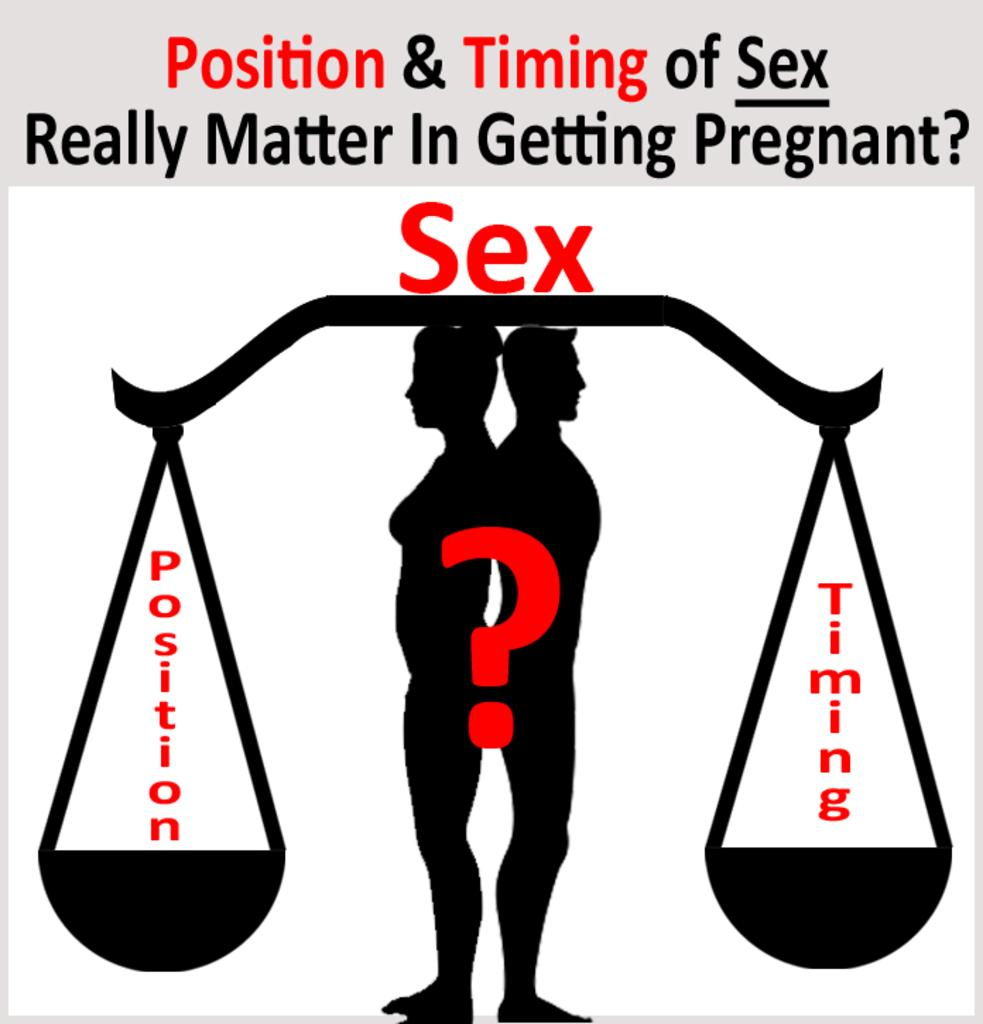<image>
Share a concise interpretation of the image provided. An ad with a couple standing with a ? discussing sexual positioning and timing. 